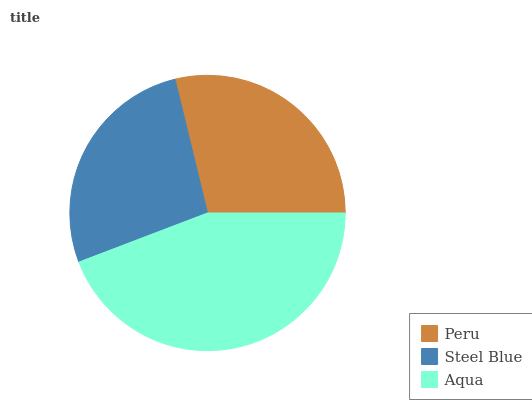Is Steel Blue the minimum?
Answer yes or no. Yes. Is Aqua the maximum?
Answer yes or no. Yes. Is Aqua the minimum?
Answer yes or no. No. Is Steel Blue the maximum?
Answer yes or no. No. Is Aqua greater than Steel Blue?
Answer yes or no. Yes. Is Steel Blue less than Aqua?
Answer yes or no. Yes. Is Steel Blue greater than Aqua?
Answer yes or no. No. Is Aqua less than Steel Blue?
Answer yes or no. No. Is Peru the high median?
Answer yes or no. Yes. Is Peru the low median?
Answer yes or no. Yes. Is Aqua the high median?
Answer yes or no. No. Is Steel Blue the low median?
Answer yes or no. No. 